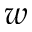<formula> <loc_0><loc_0><loc_500><loc_500>w</formula> 